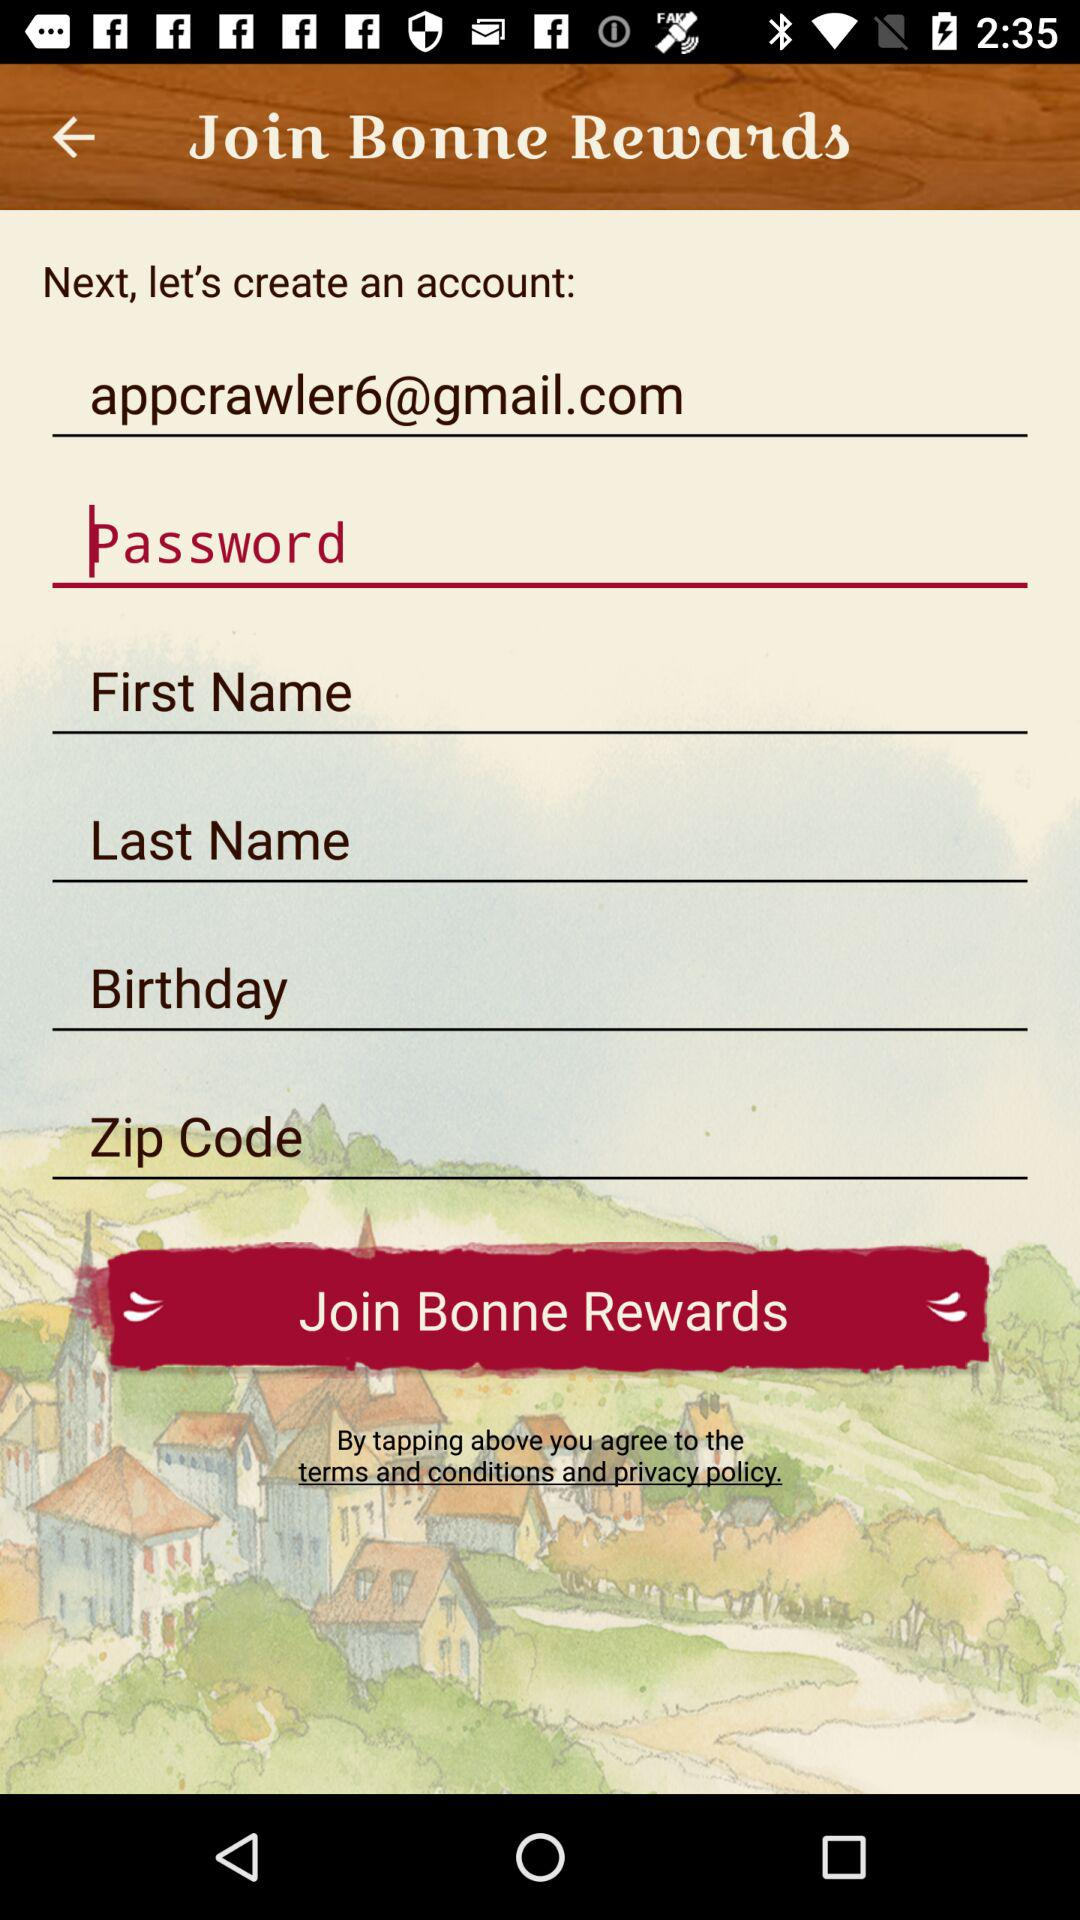What is the email address? The email address is appcrawler6@gmail.com. 